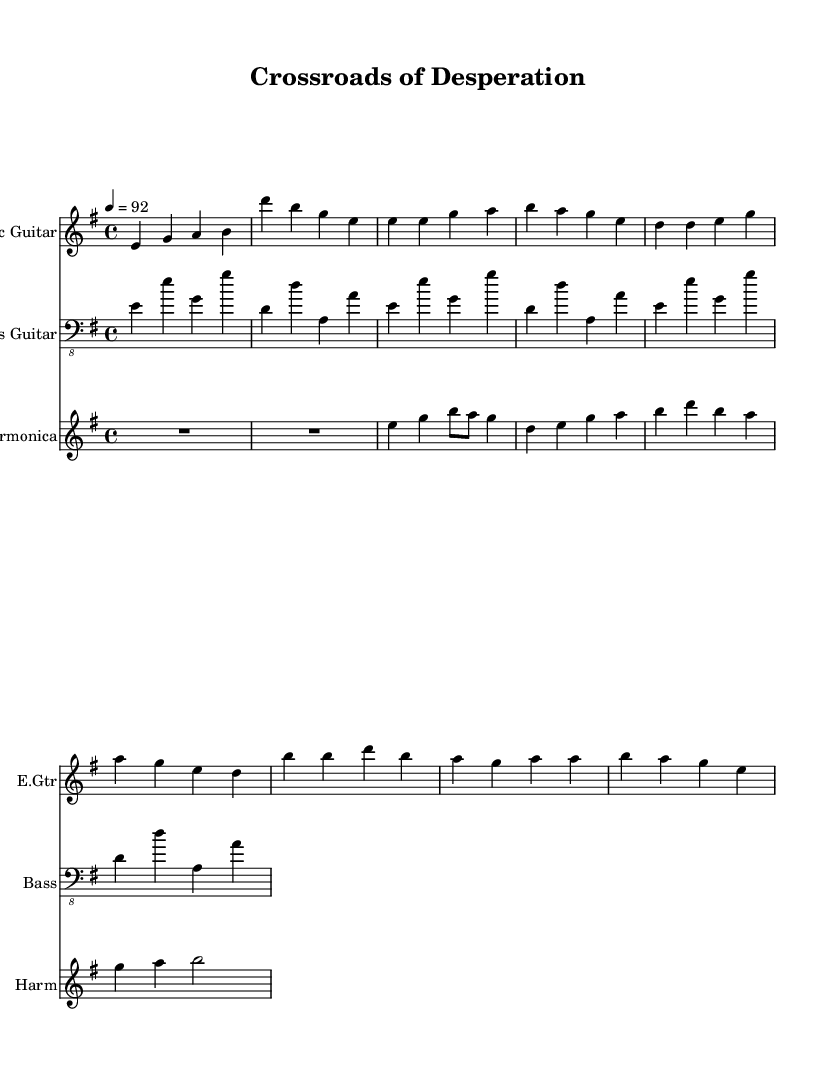What is the key signature of this music? The key signature is E minor, which has one sharp (F#). This is identified at the beginning of the sheet music right after the clef and indicates the tonal center of the piece.
Answer: E minor What is the time signature of the music? The time signature is 4/4, which is indicated at the beginning of the sheet music. This means there are four beats in each measure and a quarter note receives one beat.
Answer: 4/4 What is the tempo marking of the piece? The tempo marking is 92 BPM (beats per minute), which is shown in the tempo indication at the start of the sheet music. This signifies the speed at which the piece should be played.
Answer: 92 How many measures are there in the intro section? The intro section consists of 2 measures, as seen in the first line of music with the notes provided, ending just before the Verse 1 begins.
Answer: 2 Identify the instrument primarily featured in this piece. The instrument primarily featured in this piece is the Electric Guitar, which is the first staff listed in the score and plays the main melodic lines throughout the music.
Answer: Electric Guitar What style of music does this sheet represent? This sheet represents Electric Blues, which is evident in the music's structure and instrumentation, incorporating electric guitar, bass guitar, and harmonica, typical of the genre's characteristics.
Answer: Electric Blues How does the bass guitar part contribute to the overall feel of the music? The bass guitar part contributes a simplified walking bass line that supports the harmonic structure and rhythm, adding depth to the electric blues feel and driving the piece forward with its steady quarter notes.
Answer: Walking bass line 